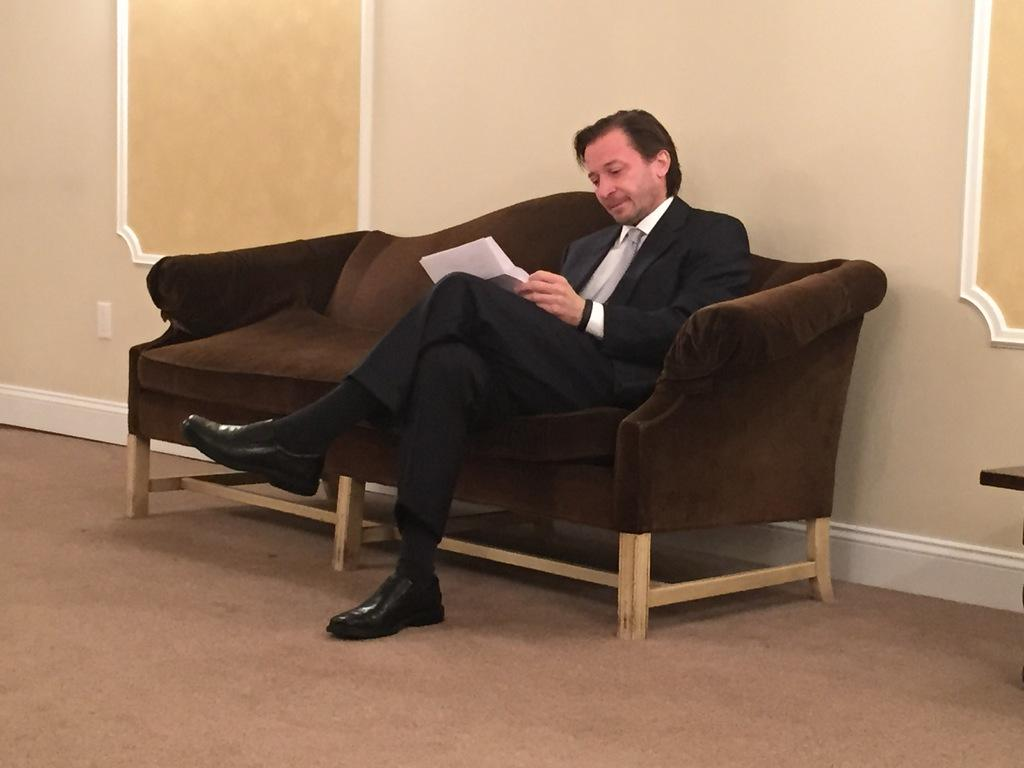What is the person in the image doing? The person is sitting on a sofa in the image. What can be seen behind the person? There is a wall in the background of the image. What is on the floor in the image? There is a carpet at the bottom of the image. How many bears are visible in the image? There are no bears present in the image. What time of day is it in the image? The time of day cannot be determined from the image, as there are no clues to indicate whether it is day or night. 